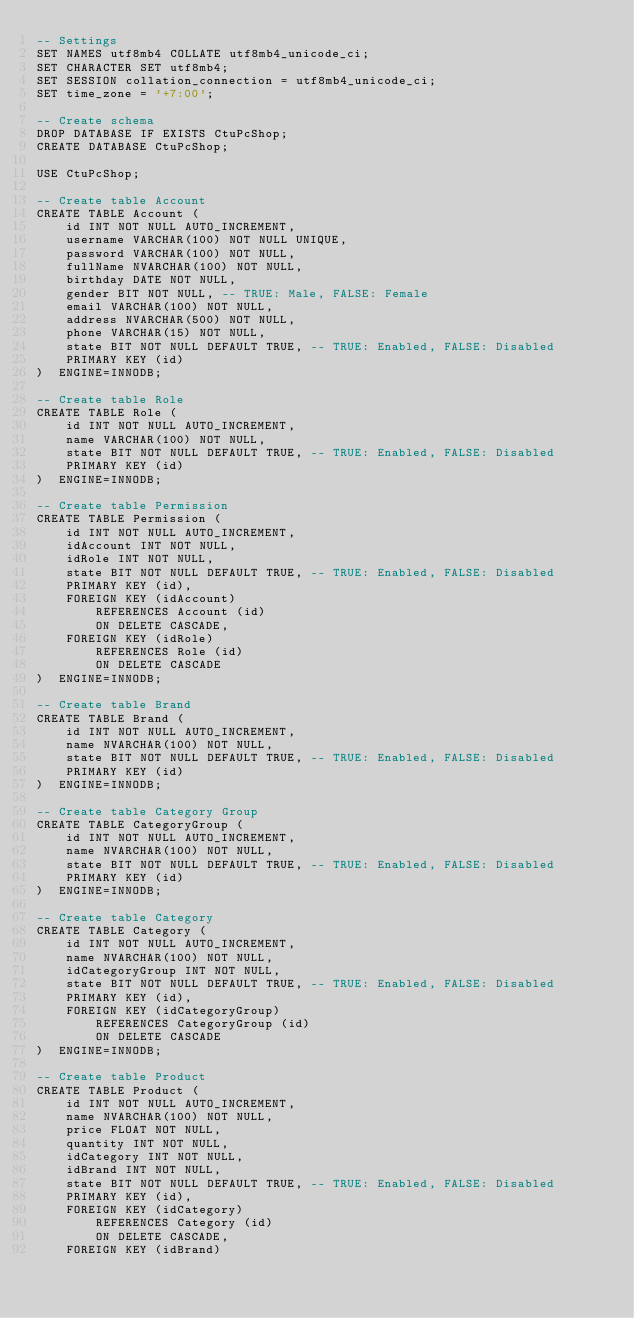<code> <loc_0><loc_0><loc_500><loc_500><_SQL_>-- Settings
SET NAMES utf8mb4 COLLATE utf8mb4_unicode_ci;
SET CHARACTER SET utf8mb4;
SET SESSION collation_connection = utf8mb4_unicode_ci;
SET time_zone = '+7:00';

-- Create schema
DROP DATABASE IF EXISTS CtuPcShop;
CREATE DATABASE CtuPcShop;

USE CtuPcShop;

-- Create table Account
CREATE TABLE Account (
    id INT NOT NULL AUTO_INCREMENT,
    username VARCHAR(100) NOT NULL UNIQUE,
    password VARCHAR(100) NOT NULL,
    fullName NVARCHAR(100) NOT NULL,
    birthday DATE NOT NULL,
    gender BIT NOT NULL, -- TRUE: Male, FALSE: Female
    email VARCHAR(100) NOT NULL,
    address NVARCHAR(500) NOT NULL,
    phone VARCHAR(15) NOT NULL,
    state BIT NOT NULL DEFAULT TRUE, -- TRUE: Enabled, FALSE: Disabled
    PRIMARY KEY (id)
)  ENGINE=INNODB;

-- Create table Role
CREATE TABLE Role (
    id INT NOT NULL AUTO_INCREMENT,
    name VARCHAR(100) NOT NULL,
    state BIT NOT NULL DEFAULT TRUE, -- TRUE: Enabled, FALSE: Disabled
    PRIMARY KEY (id)
)  ENGINE=INNODB;

-- Create table Permission
CREATE TABLE Permission (
    id INT NOT NULL AUTO_INCREMENT,
    idAccount INT NOT NULL,
    idRole INT NOT NULL,
    state BIT NOT NULL DEFAULT TRUE, -- TRUE: Enabled, FALSE: Disabled
    PRIMARY KEY (id),
    FOREIGN KEY (idAccount)
        REFERENCES Account (id)
        ON DELETE CASCADE,
    FOREIGN KEY (idRole)
        REFERENCES Role (id)
        ON DELETE CASCADE
)  ENGINE=INNODB;

-- Create table Brand
CREATE TABLE Brand (
    id INT NOT NULL AUTO_INCREMENT,
    name NVARCHAR(100) NOT NULL,
    state BIT NOT NULL DEFAULT TRUE, -- TRUE: Enabled, FALSE: Disabled
    PRIMARY KEY (id)
)  ENGINE=INNODB;

-- Create table Category Group
CREATE TABLE CategoryGroup (
    id INT NOT NULL AUTO_INCREMENT,
    name NVARCHAR(100) NOT NULL,
    state BIT NOT NULL DEFAULT TRUE, -- TRUE: Enabled, FALSE: Disabled
    PRIMARY KEY (id)
)  ENGINE=INNODB;

-- Create table Category
CREATE TABLE Category (
    id INT NOT NULL AUTO_INCREMENT,
    name NVARCHAR(100) NOT NULL,
    idCategoryGroup INT NOT NULL,
    state BIT NOT NULL DEFAULT TRUE, -- TRUE: Enabled, FALSE: Disabled
    PRIMARY KEY (id),
    FOREIGN KEY (idCategoryGroup)
        REFERENCES CategoryGroup (id)
        ON DELETE CASCADE
)  ENGINE=INNODB;

-- Create table Product
CREATE TABLE Product (
    id INT NOT NULL AUTO_INCREMENT,
    name NVARCHAR(100) NOT NULL,
    price FLOAT NOT NULL,
    quantity INT NOT NULL,
    idCategory INT NOT NULL,
    idBrand INT NOT NULL,
    state BIT NOT NULL DEFAULT TRUE, -- TRUE: Enabled, FALSE: Disabled
    PRIMARY KEY (id),
    FOREIGN KEY (idCategory)
        REFERENCES Category (id)
        ON DELETE CASCADE,
    FOREIGN KEY (idBrand)</code> 